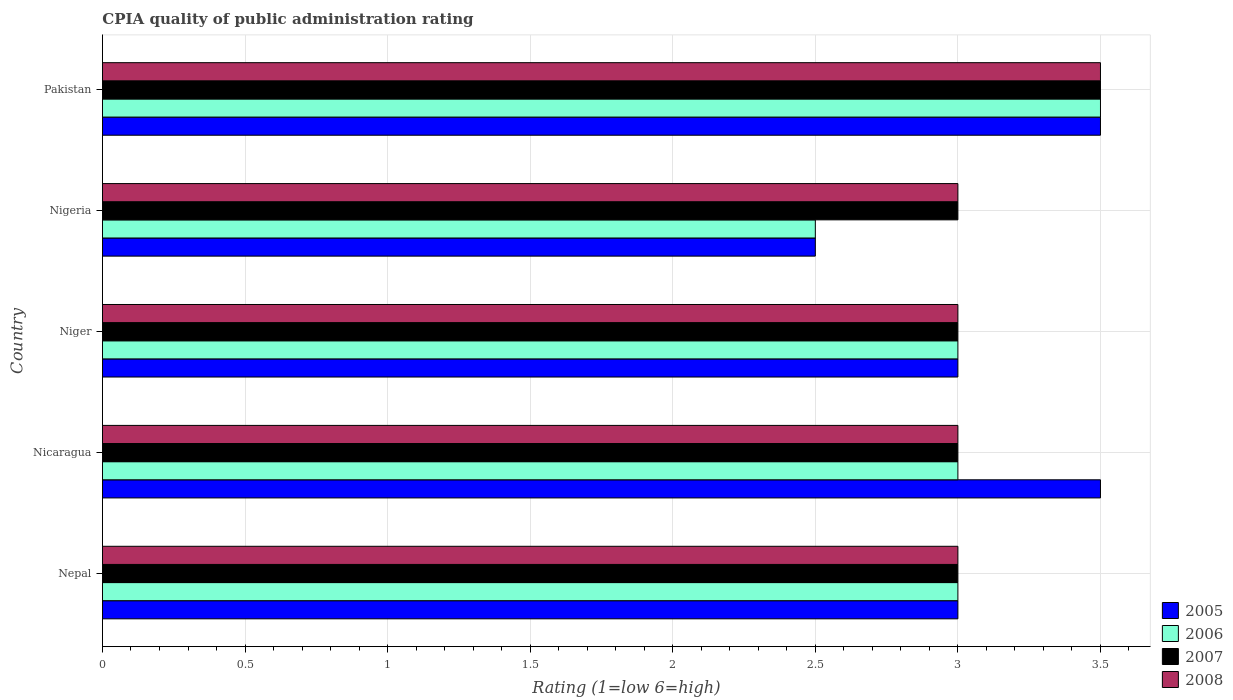How many groups of bars are there?
Your answer should be very brief. 5. Are the number of bars per tick equal to the number of legend labels?
Ensure brevity in your answer.  Yes. How many bars are there on the 1st tick from the bottom?
Your answer should be very brief. 4. What is the label of the 2nd group of bars from the top?
Ensure brevity in your answer.  Nigeria. In how many cases, is the number of bars for a given country not equal to the number of legend labels?
Give a very brief answer. 0. What is the CPIA rating in 2005 in Pakistan?
Make the answer very short. 3.5. In which country was the CPIA rating in 2008 minimum?
Offer a very short reply. Nepal. What is the total CPIA rating in 2005 in the graph?
Keep it short and to the point. 15.5. What is the difference between the CPIA rating in 2006 in Nicaragua and that in Pakistan?
Provide a short and direct response. -0.5. What is the average CPIA rating in 2005 per country?
Provide a succinct answer. 3.1. In how many countries, is the CPIA rating in 2007 greater than 2.2 ?
Your response must be concise. 5. Is the CPIA rating in 2007 in Nicaragua less than that in Nigeria?
Give a very brief answer. No. What is the difference between the highest and the second highest CPIA rating in 2005?
Offer a very short reply. 0. What is the difference between the highest and the lowest CPIA rating in 2008?
Ensure brevity in your answer.  0.5. Is the sum of the CPIA rating in 2005 in Nicaragua and Niger greater than the maximum CPIA rating in 2008 across all countries?
Keep it short and to the point. Yes. Is it the case that in every country, the sum of the CPIA rating in 2005 and CPIA rating in 2008 is greater than the sum of CPIA rating in 2006 and CPIA rating in 2007?
Offer a terse response. No. What does the 1st bar from the top in Nepal represents?
Offer a very short reply. 2008. What does the 2nd bar from the bottom in Nigeria represents?
Offer a terse response. 2006. Is it the case that in every country, the sum of the CPIA rating in 2008 and CPIA rating in 2007 is greater than the CPIA rating in 2006?
Your answer should be compact. Yes. How many bars are there?
Give a very brief answer. 20. Are all the bars in the graph horizontal?
Make the answer very short. Yes. What is the difference between two consecutive major ticks on the X-axis?
Ensure brevity in your answer.  0.5. Are the values on the major ticks of X-axis written in scientific E-notation?
Your answer should be very brief. No. Does the graph contain any zero values?
Offer a very short reply. No. Where does the legend appear in the graph?
Offer a terse response. Bottom right. How are the legend labels stacked?
Keep it short and to the point. Vertical. What is the title of the graph?
Your answer should be compact. CPIA quality of public administration rating. Does "1967" appear as one of the legend labels in the graph?
Provide a succinct answer. No. What is the label or title of the Y-axis?
Provide a short and direct response. Country. What is the Rating (1=low 6=high) of 2005 in Nepal?
Make the answer very short. 3. What is the Rating (1=low 6=high) of 2006 in Nepal?
Keep it short and to the point. 3. What is the Rating (1=low 6=high) in 2005 in Nicaragua?
Offer a very short reply. 3.5. What is the Rating (1=low 6=high) of 2007 in Nicaragua?
Provide a short and direct response. 3. What is the Rating (1=low 6=high) in 2008 in Nicaragua?
Give a very brief answer. 3. What is the Rating (1=low 6=high) in 2005 in Niger?
Make the answer very short. 3. What is the Rating (1=low 6=high) of 2006 in Niger?
Provide a succinct answer. 3. What is the Rating (1=low 6=high) in 2007 in Niger?
Your answer should be very brief. 3. What is the Rating (1=low 6=high) of 2008 in Niger?
Your answer should be very brief. 3. What is the Rating (1=low 6=high) of 2005 in Nigeria?
Offer a terse response. 2.5. What is the Rating (1=low 6=high) in 2005 in Pakistan?
Provide a short and direct response. 3.5. What is the Rating (1=low 6=high) of 2007 in Pakistan?
Ensure brevity in your answer.  3.5. What is the Rating (1=low 6=high) in 2008 in Pakistan?
Your answer should be very brief. 3.5. Across all countries, what is the maximum Rating (1=low 6=high) of 2005?
Provide a succinct answer. 3.5. Across all countries, what is the minimum Rating (1=low 6=high) of 2006?
Provide a succinct answer. 2.5. Across all countries, what is the minimum Rating (1=low 6=high) in 2007?
Ensure brevity in your answer.  3. Across all countries, what is the minimum Rating (1=low 6=high) in 2008?
Offer a very short reply. 3. What is the difference between the Rating (1=low 6=high) in 2006 in Nepal and that in Nicaragua?
Provide a short and direct response. 0. What is the difference between the Rating (1=low 6=high) in 2007 in Nepal and that in Niger?
Offer a terse response. 0. What is the difference between the Rating (1=low 6=high) in 2008 in Nepal and that in Niger?
Provide a short and direct response. 0. What is the difference between the Rating (1=low 6=high) in 2007 in Nepal and that in Nigeria?
Your answer should be compact. 0. What is the difference between the Rating (1=low 6=high) in 2008 in Nepal and that in Nigeria?
Your answer should be very brief. 0. What is the difference between the Rating (1=low 6=high) in 2005 in Nepal and that in Pakistan?
Ensure brevity in your answer.  -0.5. What is the difference between the Rating (1=low 6=high) in 2006 in Nepal and that in Pakistan?
Offer a terse response. -0.5. What is the difference between the Rating (1=low 6=high) in 2005 in Nicaragua and that in Niger?
Provide a short and direct response. 0.5. What is the difference between the Rating (1=low 6=high) in 2007 in Nicaragua and that in Niger?
Your answer should be very brief. 0. What is the difference between the Rating (1=low 6=high) of 2008 in Nicaragua and that in Niger?
Offer a terse response. 0. What is the difference between the Rating (1=low 6=high) in 2005 in Nicaragua and that in Nigeria?
Keep it short and to the point. 1. What is the difference between the Rating (1=low 6=high) of 2006 in Nicaragua and that in Nigeria?
Provide a short and direct response. 0.5. What is the difference between the Rating (1=low 6=high) in 2007 in Nicaragua and that in Nigeria?
Your answer should be compact. 0. What is the difference between the Rating (1=low 6=high) in 2008 in Nicaragua and that in Nigeria?
Your answer should be compact. 0. What is the difference between the Rating (1=low 6=high) of 2006 in Nicaragua and that in Pakistan?
Your response must be concise. -0.5. What is the difference between the Rating (1=low 6=high) in 2007 in Nicaragua and that in Pakistan?
Give a very brief answer. -0.5. What is the difference between the Rating (1=low 6=high) in 2008 in Nicaragua and that in Pakistan?
Ensure brevity in your answer.  -0.5. What is the difference between the Rating (1=low 6=high) in 2007 in Niger and that in Nigeria?
Offer a very short reply. 0. What is the difference between the Rating (1=low 6=high) in 2008 in Niger and that in Nigeria?
Ensure brevity in your answer.  0. What is the difference between the Rating (1=low 6=high) of 2006 in Niger and that in Pakistan?
Your response must be concise. -0.5. What is the difference between the Rating (1=low 6=high) in 2007 in Niger and that in Pakistan?
Your answer should be very brief. -0.5. What is the difference between the Rating (1=low 6=high) of 2005 in Nigeria and that in Pakistan?
Your answer should be compact. -1. What is the difference between the Rating (1=low 6=high) of 2005 in Nepal and the Rating (1=low 6=high) of 2006 in Nicaragua?
Offer a very short reply. 0. What is the difference between the Rating (1=low 6=high) in 2005 in Nepal and the Rating (1=low 6=high) in 2007 in Nicaragua?
Your response must be concise. 0. What is the difference between the Rating (1=low 6=high) of 2005 in Nepal and the Rating (1=low 6=high) of 2008 in Nicaragua?
Keep it short and to the point. 0. What is the difference between the Rating (1=low 6=high) of 2006 in Nepal and the Rating (1=low 6=high) of 2008 in Nicaragua?
Keep it short and to the point. 0. What is the difference between the Rating (1=low 6=high) of 2007 in Nepal and the Rating (1=low 6=high) of 2008 in Nicaragua?
Give a very brief answer. 0. What is the difference between the Rating (1=low 6=high) of 2005 in Nepal and the Rating (1=low 6=high) of 2006 in Niger?
Your answer should be compact. 0. What is the difference between the Rating (1=low 6=high) in 2006 in Nepal and the Rating (1=low 6=high) in 2007 in Niger?
Offer a terse response. 0. What is the difference between the Rating (1=low 6=high) of 2006 in Nepal and the Rating (1=low 6=high) of 2008 in Niger?
Keep it short and to the point. 0. What is the difference between the Rating (1=low 6=high) of 2005 in Nepal and the Rating (1=low 6=high) of 2006 in Nigeria?
Ensure brevity in your answer.  0.5. What is the difference between the Rating (1=low 6=high) in 2005 in Nepal and the Rating (1=low 6=high) in 2007 in Nigeria?
Your answer should be compact. 0. What is the difference between the Rating (1=low 6=high) of 2005 in Nepal and the Rating (1=low 6=high) of 2008 in Nigeria?
Provide a succinct answer. 0. What is the difference between the Rating (1=low 6=high) in 2006 in Nepal and the Rating (1=low 6=high) in 2007 in Nigeria?
Make the answer very short. 0. What is the difference between the Rating (1=low 6=high) of 2006 in Nepal and the Rating (1=low 6=high) of 2008 in Nigeria?
Ensure brevity in your answer.  0. What is the difference between the Rating (1=low 6=high) of 2007 in Nepal and the Rating (1=low 6=high) of 2008 in Nigeria?
Your response must be concise. 0. What is the difference between the Rating (1=low 6=high) in 2005 in Nepal and the Rating (1=low 6=high) in 2006 in Pakistan?
Your answer should be very brief. -0.5. What is the difference between the Rating (1=low 6=high) in 2005 in Nepal and the Rating (1=low 6=high) in 2007 in Pakistan?
Provide a succinct answer. -0.5. What is the difference between the Rating (1=low 6=high) of 2006 in Nepal and the Rating (1=low 6=high) of 2008 in Pakistan?
Offer a terse response. -0.5. What is the difference between the Rating (1=low 6=high) of 2007 in Nepal and the Rating (1=low 6=high) of 2008 in Pakistan?
Provide a succinct answer. -0.5. What is the difference between the Rating (1=low 6=high) in 2005 in Nicaragua and the Rating (1=low 6=high) in 2006 in Niger?
Your response must be concise. 0.5. What is the difference between the Rating (1=low 6=high) in 2005 in Nicaragua and the Rating (1=low 6=high) in 2007 in Niger?
Provide a short and direct response. 0.5. What is the difference between the Rating (1=low 6=high) in 2005 in Nicaragua and the Rating (1=low 6=high) in 2008 in Niger?
Ensure brevity in your answer.  0.5. What is the difference between the Rating (1=low 6=high) of 2006 in Nicaragua and the Rating (1=low 6=high) of 2007 in Niger?
Give a very brief answer. 0. What is the difference between the Rating (1=low 6=high) of 2006 in Nicaragua and the Rating (1=low 6=high) of 2008 in Nigeria?
Provide a succinct answer. 0. What is the difference between the Rating (1=low 6=high) of 2007 in Nicaragua and the Rating (1=low 6=high) of 2008 in Nigeria?
Ensure brevity in your answer.  0. What is the difference between the Rating (1=low 6=high) of 2005 in Nicaragua and the Rating (1=low 6=high) of 2006 in Pakistan?
Your answer should be very brief. 0. What is the difference between the Rating (1=low 6=high) in 2005 in Nicaragua and the Rating (1=low 6=high) in 2008 in Pakistan?
Your answer should be compact. 0. What is the difference between the Rating (1=low 6=high) of 2006 in Nicaragua and the Rating (1=low 6=high) of 2008 in Pakistan?
Provide a succinct answer. -0.5. What is the difference between the Rating (1=low 6=high) in 2007 in Nicaragua and the Rating (1=low 6=high) in 2008 in Pakistan?
Your answer should be compact. -0.5. What is the difference between the Rating (1=low 6=high) in 2005 in Niger and the Rating (1=low 6=high) in 2006 in Nigeria?
Give a very brief answer. 0.5. What is the difference between the Rating (1=low 6=high) of 2005 in Niger and the Rating (1=low 6=high) of 2008 in Nigeria?
Your answer should be very brief. 0. What is the difference between the Rating (1=low 6=high) in 2006 in Niger and the Rating (1=low 6=high) in 2007 in Nigeria?
Give a very brief answer. 0. What is the difference between the Rating (1=low 6=high) of 2005 in Niger and the Rating (1=low 6=high) of 2006 in Pakistan?
Give a very brief answer. -0.5. What is the difference between the Rating (1=low 6=high) in 2005 in Niger and the Rating (1=low 6=high) in 2008 in Pakistan?
Your response must be concise. -0.5. What is the difference between the Rating (1=low 6=high) of 2006 in Niger and the Rating (1=low 6=high) of 2007 in Pakistan?
Keep it short and to the point. -0.5. What is the difference between the Rating (1=low 6=high) of 2005 in Nigeria and the Rating (1=low 6=high) of 2007 in Pakistan?
Your answer should be very brief. -1. What is the difference between the Rating (1=low 6=high) of 2006 in Nigeria and the Rating (1=low 6=high) of 2007 in Pakistan?
Your answer should be compact. -1. What is the difference between the Rating (1=low 6=high) of 2006 in Nigeria and the Rating (1=low 6=high) of 2008 in Pakistan?
Your response must be concise. -1. What is the difference between the Rating (1=low 6=high) in 2007 in Nigeria and the Rating (1=low 6=high) in 2008 in Pakistan?
Make the answer very short. -0.5. What is the average Rating (1=low 6=high) of 2005 per country?
Offer a terse response. 3.1. What is the average Rating (1=low 6=high) in 2006 per country?
Offer a terse response. 3. What is the difference between the Rating (1=low 6=high) of 2006 and Rating (1=low 6=high) of 2007 in Nepal?
Your answer should be compact. 0. What is the difference between the Rating (1=low 6=high) in 2006 and Rating (1=low 6=high) in 2008 in Nepal?
Your response must be concise. 0. What is the difference between the Rating (1=low 6=high) in 2005 and Rating (1=low 6=high) in 2007 in Nicaragua?
Offer a very short reply. 0.5. What is the difference between the Rating (1=low 6=high) in 2006 and Rating (1=low 6=high) in 2007 in Nicaragua?
Keep it short and to the point. 0. What is the difference between the Rating (1=low 6=high) in 2007 and Rating (1=low 6=high) in 2008 in Nicaragua?
Keep it short and to the point. 0. What is the difference between the Rating (1=low 6=high) in 2005 and Rating (1=low 6=high) in 2006 in Niger?
Keep it short and to the point. 0. What is the difference between the Rating (1=low 6=high) in 2006 and Rating (1=low 6=high) in 2007 in Niger?
Offer a very short reply. 0. What is the difference between the Rating (1=low 6=high) in 2006 and Rating (1=low 6=high) in 2008 in Niger?
Offer a terse response. 0. What is the difference between the Rating (1=low 6=high) of 2005 and Rating (1=low 6=high) of 2006 in Nigeria?
Provide a succinct answer. 0. What is the difference between the Rating (1=low 6=high) of 2005 and Rating (1=low 6=high) of 2007 in Nigeria?
Ensure brevity in your answer.  -0.5. What is the difference between the Rating (1=low 6=high) in 2007 and Rating (1=low 6=high) in 2008 in Nigeria?
Provide a short and direct response. 0. What is the difference between the Rating (1=low 6=high) of 2005 and Rating (1=low 6=high) of 2006 in Pakistan?
Your response must be concise. 0. What is the difference between the Rating (1=low 6=high) of 2005 and Rating (1=low 6=high) of 2007 in Pakistan?
Your response must be concise. 0. What is the difference between the Rating (1=low 6=high) in 2006 and Rating (1=low 6=high) in 2007 in Pakistan?
Keep it short and to the point. 0. What is the difference between the Rating (1=low 6=high) in 2006 and Rating (1=low 6=high) in 2008 in Pakistan?
Offer a very short reply. 0. What is the ratio of the Rating (1=low 6=high) in 2008 in Nepal to that in Nicaragua?
Your response must be concise. 1. What is the ratio of the Rating (1=low 6=high) in 2005 in Nepal to that in Niger?
Make the answer very short. 1. What is the ratio of the Rating (1=low 6=high) of 2006 in Nepal to that in Niger?
Your answer should be compact. 1. What is the ratio of the Rating (1=low 6=high) of 2007 in Nepal to that in Niger?
Provide a short and direct response. 1. What is the ratio of the Rating (1=low 6=high) of 2008 in Nepal to that in Nigeria?
Your answer should be compact. 1. What is the ratio of the Rating (1=low 6=high) of 2005 in Nicaragua to that in Niger?
Provide a succinct answer. 1.17. What is the ratio of the Rating (1=low 6=high) in 2006 in Nicaragua to that in Niger?
Make the answer very short. 1. What is the ratio of the Rating (1=low 6=high) of 2008 in Nicaragua to that in Niger?
Ensure brevity in your answer.  1. What is the ratio of the Rating (1=low 6=high) of 2005 in Nicaragua to that in Nigeria?
Give a very brief answer. 1.4. What is the ratio of the Rating (1=low 6=high) of 2008 in Nicaragua to that in Pakistan?
Keep it short and to the point. 0.86. What is the ratio of the Rating (1=low 6=high) in 2005 in Niger to that in Nigeria?
Offer a very short reply. 1.2. What is the ratio of the Rating (1=low 6=high) in 2006 in Niger to that in Nigeria?
Your response must be concise. 1.2. What is the ratio of the Rating (1=low 6=high) of 2008 in Niger to that in Nigeria?
Keep it short and to the point. 1. What is the ratio of the Rating (1=low 6=high) in 2006 in Niger to that in Pakistan?
Offer a very short reply. 0.86. What is the ratio of the Rating (1=low 6=high) of 2007 in Niger to that in Pakistan?
Your response must be concise. 0.86. What is the ratio of the Rating (1=low 6=high) of 2006 in Nigeria to that in Pakistan?
Keep it short and to the point. 0.71. What is the difference between the highest and the second highest Rating (1=low 6=high) in 2007?
Offer a very short reply. 0.5. What is the difference between the highest and the second highest Rating (1=low 6=high) of 2008?
Provide a short and direct response. 0.5. What is the difference between the highest and the lowest Rating (1=low 6=high) in 2006?
Keep it short and to the point. 1. What is the difference between the highest and the lowest Rating (1=low 6=high) in 2008?
Your answer should be compact. 0.5. 